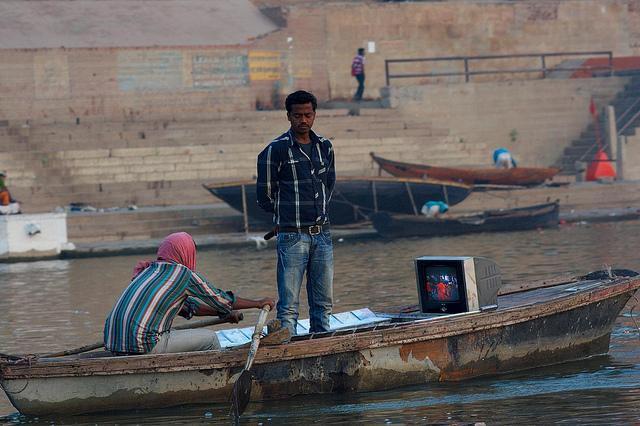How many boats do you see?
Give a very brief answer. 4. How many people can be seen?
Give a very brief answer. 2. How many boats are there?
Give a very brief answer. 4. How many skiiers are standing to the right of the train car?
Give a very brief answer. 0. 